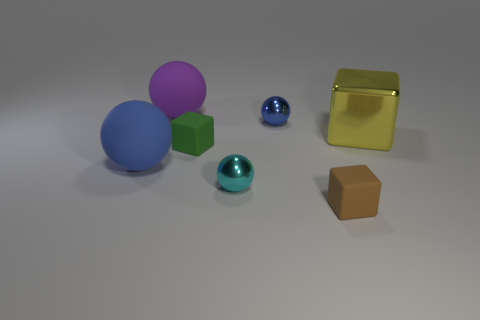Do the green matte object and the tiny brown rubber object have the same shape? yes 